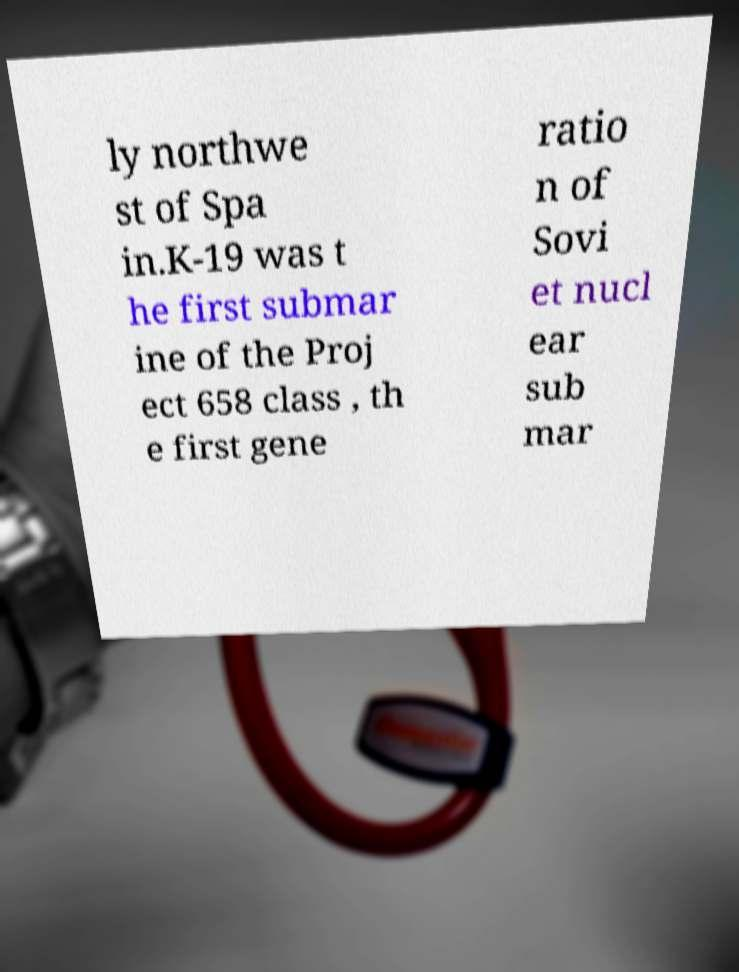Please identify and transcribe the text found in this image. ly northwe st of Spa in.K-19 was t he first submar ine of the Proj ect 658 class , th e first gene ratio n of Sovi et nucl ear sub mar 